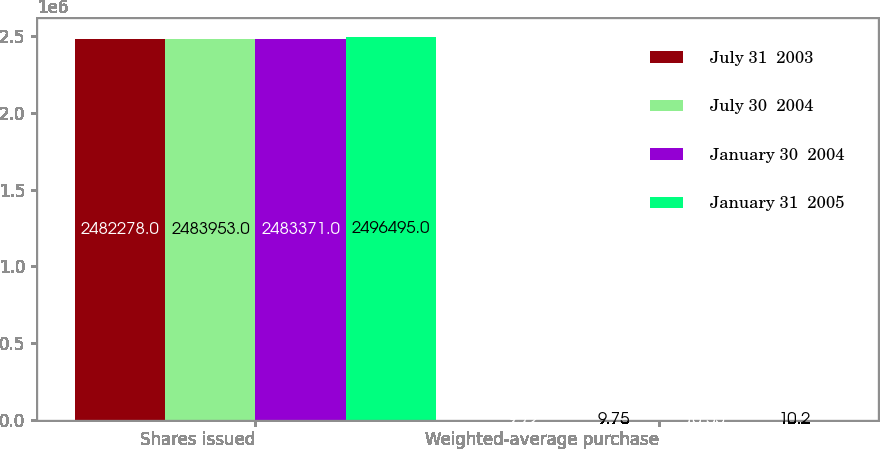Convert chart to OTSL. <chart><loc_0><loc_0><loc_500><loc_500><stacked_bar_chart><ecel><fcel>Shares issued<fcel>Weighted-average purchase<nl><fcel>July 31  2003<fcel>2.48228e+06<fcel>9.72<nl><fcel>July 30  2004<fcel>2.48395e+06<fcel>9.75<nl><fcel>January 30  2004<fcel>2.48337e+06<fcel>10.55<nl><fcel>January 31  2005<fcel>2.4965e+06<fcel>10.2<nl></chart> 